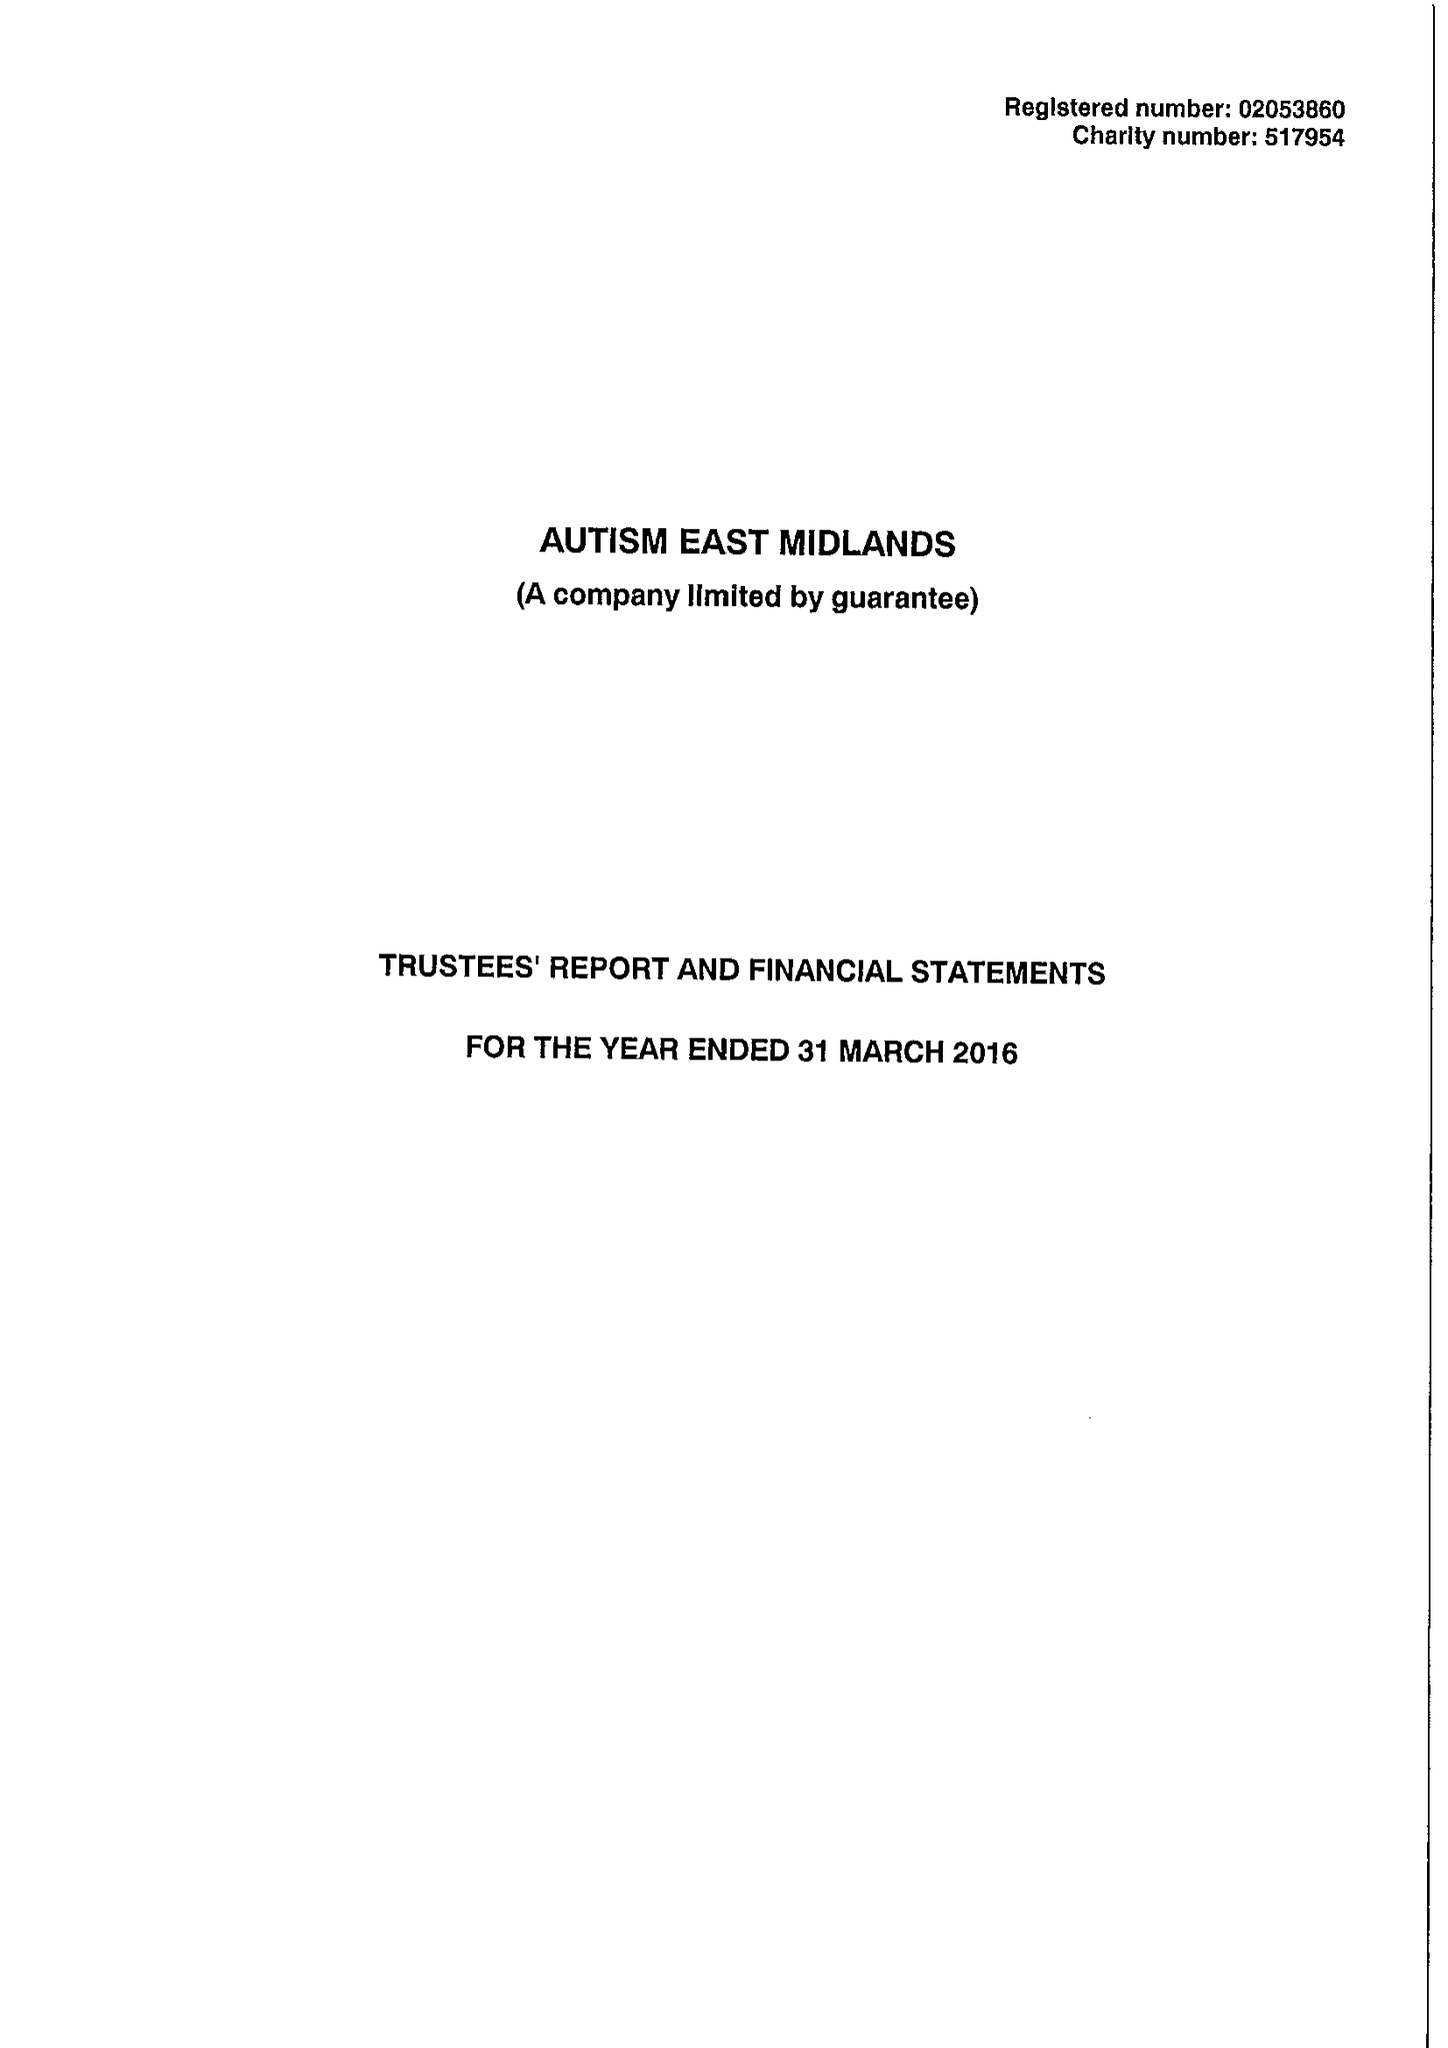What is the value for the spending_annually_in_british_pounds?
Answer the question using a single word or phrase. 11970020.00 